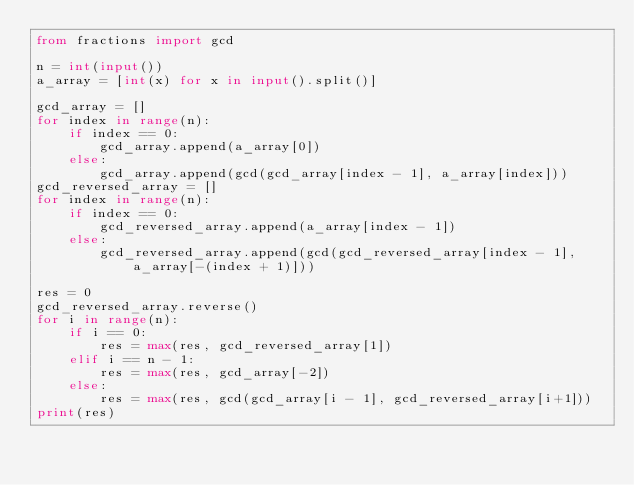<code> <loc_0><loc_0><loc_500><loc_500><_Python_>from fractions import gcd

n = int(input())
a_array = [int(x) for x in input().split()]

gcd_array = []
for index in range(n):
    if index == 0:
        gcd_array.append(a_array[0])
    else:
        gcd_array.append(gcd(gcd_array[index - 1], a_array[index]))
gcd_reversed_array = []
for index in range(n):
    if index == 0:
        gcd_reversed_array.append(a_array[index - 1])
    else:
        gcd_reversed_array.append(gcd(gcd_reversed_array[index - 1], a_array[-(index + 1)]))

res = 0
gcd_reversed_array.reverse()
for i in range(n):
    if i == 0:
        res = max(res, gcd_reversed_array[1])
    elif i == n - 1:
        res = max(res, gcd_array[-2])
    else:
        res = max(res, gcd(gcd_array[i - 1], gcd_reversed_array[i+1]))
print(res)
</code> 